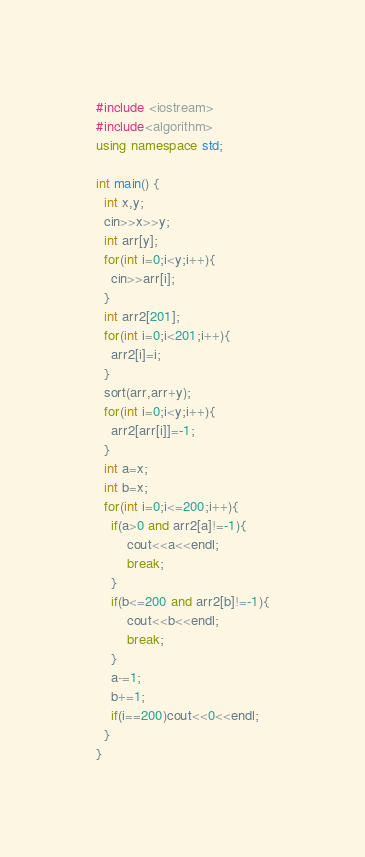Convert code to text. <code><loc_0><loc_0><loc_500><loc_500><_C++_>#include <iostream>
#include<algorithm>
using namespace std;

int main() {
  int x,y;
  cin>>x>>y;
  int arr[y];
  for(int i=0;i<y;i++){
  	cin>>arr[i];
  }
  int arr2[201];
  for(int i=0;i<201;i++){
  	arr2[i]=i;
  }  
  sort(arr,arr+y);
  for(int i=0;i<y;i++){
  	arr2[arr[i]]=-1;
  }
  int a=x;
  int b=x;
  for(int i=0;i<=200;i++){
    if(a>0 and arr2[a]!=-1){
    	cout<<a<<endl;
    	break;
    }
    if(b<=200 and arr2[b]!=-1){
    	cout<<b<<endl;
    	break;
    }
    a-=1;
    b+=1;
    if(i==200)cout<<0<<endl;
  }
}















</code> 